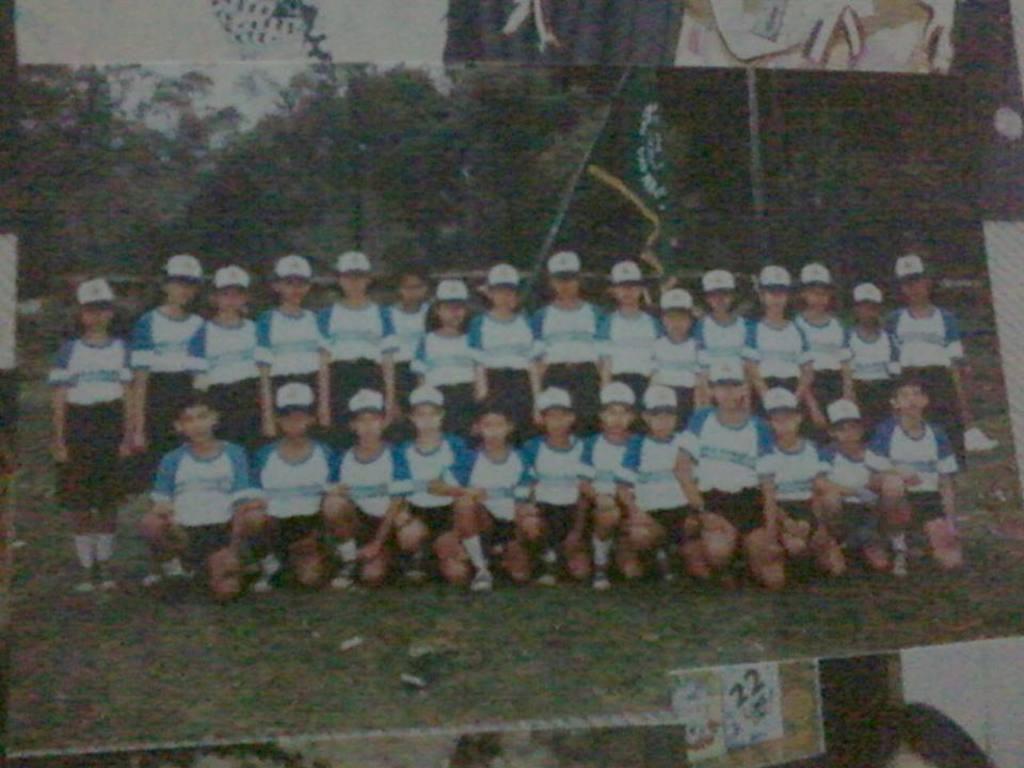Could you give a brief overview of what you see in this image? In this image there is a photo, in that photo there are people standing few are laying on their knees. 